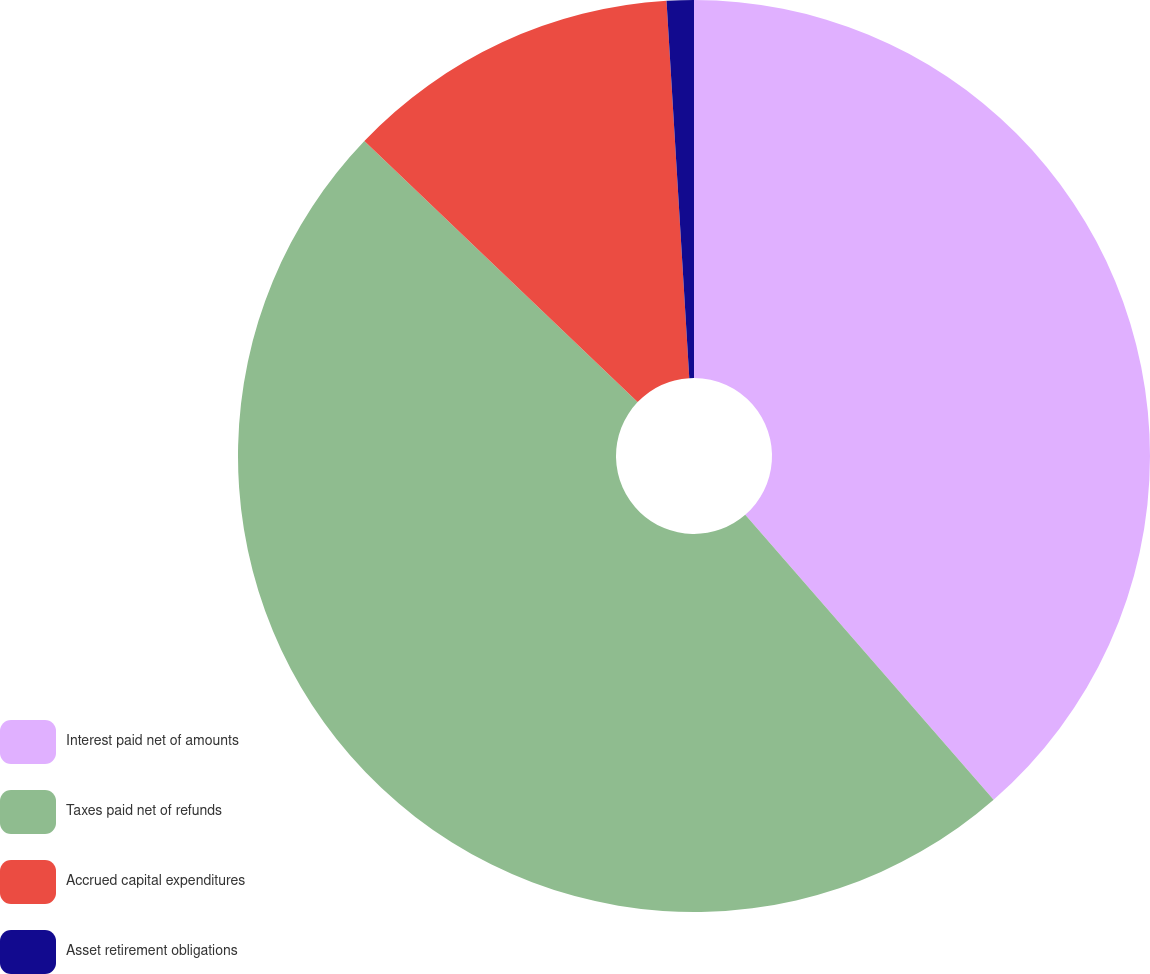<chart> <loc_0><loc_0><loc_500><loc_500><pie_chart><fcel>Interest paid net of amounts<fcel>Taxes paid net of refunds<fcel>Accrued capital expenditures<fcel>Asset retirement obligations<nl><fcel>38.59%<fcel>48.55%<fcel>11.9%<fcel>0.96%<nl></chart> 